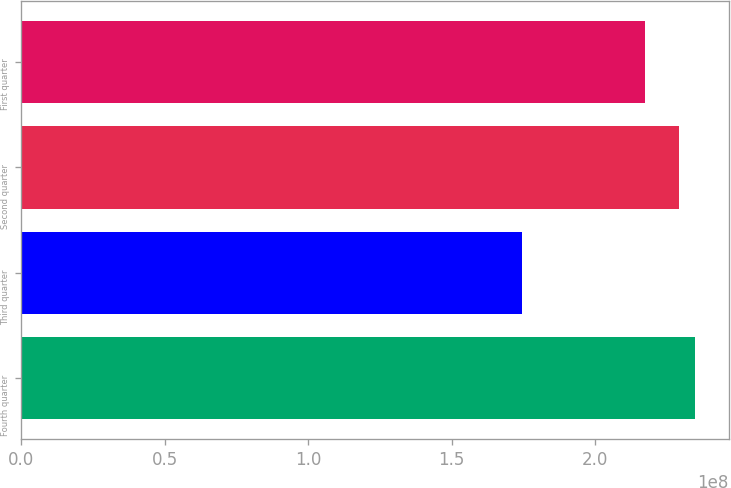Convert chart. <chart><loc_0><loc_0><loc_500><loc_500><bar_chart><fcel>Fourth quarter<fcel>Third quarter<fcel>Second quarter<fcel>First quarter<nl><fcel>2.34824e+08<fcel>1.74417e+08<fcel>2.29247e+08<fcel>2.1744e+08<nl></chart> 